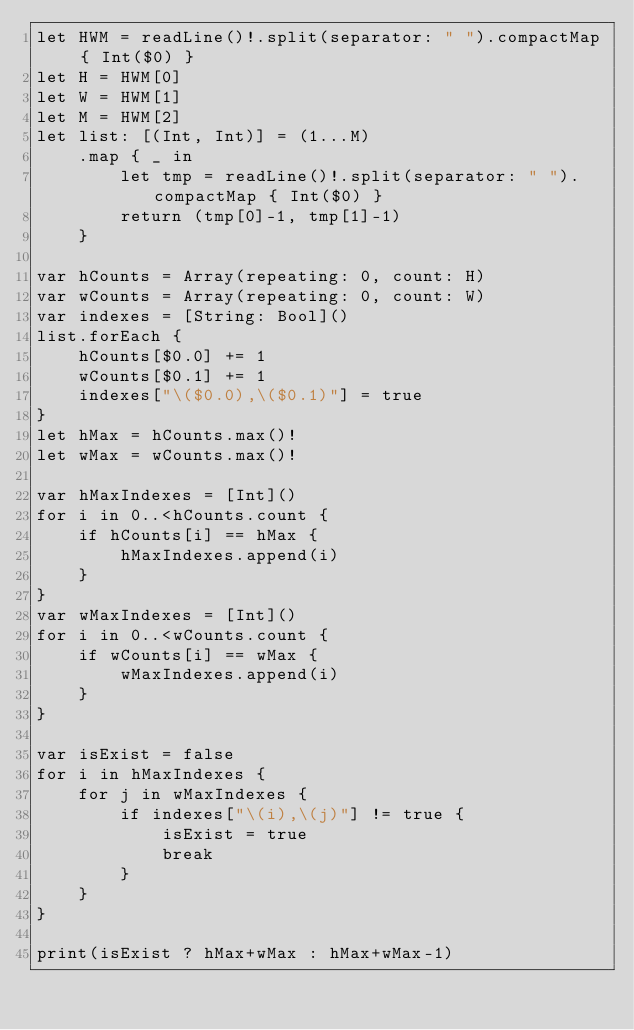Convert code to text. <code><loc_0><loc_0><loc_500><loc_500><_Swift_>let HWM = readLine()!.split(separator: " ").compactMap { Int($0) }
let H = HWM[0]
let W = HWM[1]
let M = HWM[2]
let list: [(Int, Int)] = (1...M)
    .map { _ in
        let tmp = readLine()!.split(separator: " ").compactMap { Int($0) }
        return (tmp[0]-1, tmp[1]-1)
    }

var hCounts = Array(repeating: 0, count: H)
var wCounts = Array(repeating: 0, count: W)
var indexes = [String: Bool]()
list.forEach {
    hCounts[$0.0] += 1
    wCounts[$0.1] += 1
    indexes["\($0.0),\($0.1)"] = true
}
let hMax = hCounts.max()!
let wMax = wCounts.max()!

var hMaxIndexes = [Int]()
for i in 0..<hCounts.count {
    if hCounts[i] == hMax {
        hMaxIndexes.append(i)
    }
}
var wMaxIndexes = [Int]()
for i in 0..<wCounts.count {
    if wCounts[i] == wMax {
        wMaxIndexes.append(i)
    }
}

var isExist = false
for i in hMaxIndexes {
    for j in wMaxIndexes {
        if indexes["\(i),\(j)"] != true {
            isExist = true
            break
        }
    }
}

print(isExist ? hMax+wMax : hMax+wMax-1)
</code> 